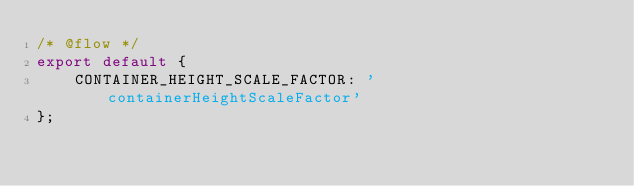<code> <loc_0><loc_0><loc_500><loc_500><_JavaScript_>/* @flow */
export default {
    CONTAINER_HEIGHT_SCALE_FACTOR: 'containerHeightScaleFactor'
};
</code> 